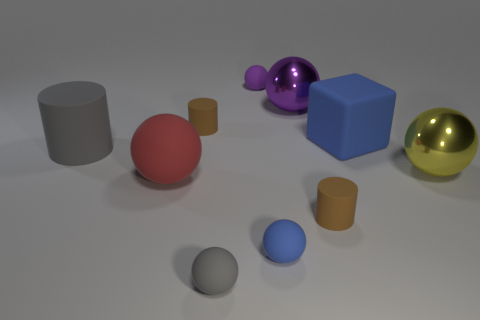Subtract all tiny cylinders. How many cylinders are left? 1 Subtract all gray cylinders. How many cylinders are left? 2 Subtract all gray spheres. How many gray cylinders are left? 1 Subtract all small yellow matte cubes. Subtract all big red rubber things. How many objects are left? 9 Add 4 metal things. How many metal things are left? 6 Add 2 big spheres. How many big spheres exist? 5 Subtract 1 gray spheres. How many objects are left? 9 Subtract all cylinders. How many objects are left? 7 Subtract 2 balls. How many balls are left? 4 Subtract all purple cylinders. Subtract all green cubes. How many cylinders are left? 3 